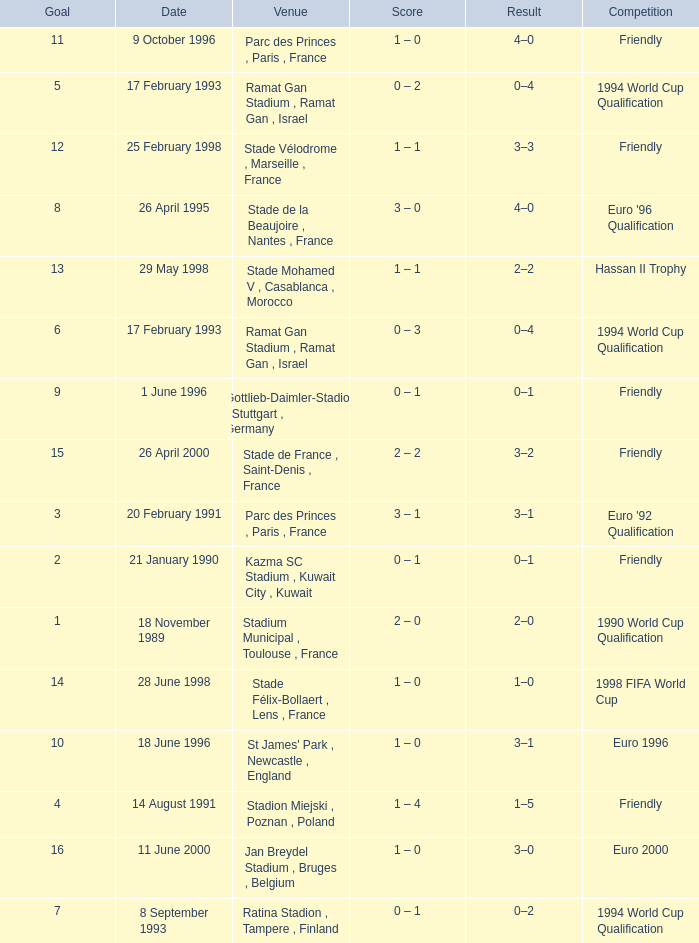What was the date of the game with a goal of 7? 8 September 1993. 